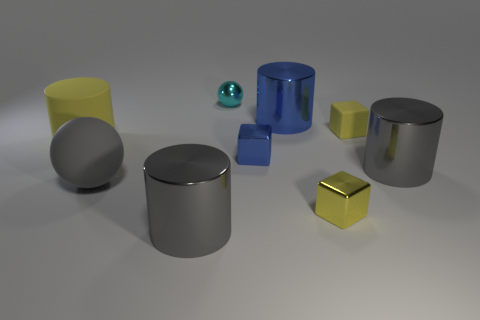Add 1 small blue shiny cubes. How many objects exist? 10 Subtract all cylinders. How many objects are left? 5 Add 5 big metallic objects. How many big metallic objects exist? 8 Subtract 1 yellow cubes. How many objects are left? 8 Subtract all blue cylinders. Subtract all yellow cylinders. How many objects are left? 7 Add 3 large rubber things. How many large rubber things are left? 5 